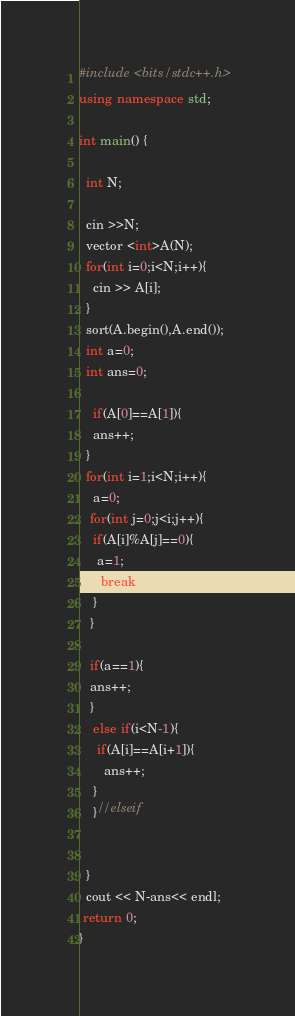<code> <loc_0><loc_0><loc_500><loc_500><_C++_>#include <bits/stdc++.h>
using namespace std;

int main() {

  int N;

  cin >>N;
  vector <int>A(N);
  for(int i=0;i<N;i++){
    cin >> A[i];
  }
  sort(A.begin(),A.end());
  int a=0;
  int ans=0;

    if(A[0]==A[1]){
    ans++;
  }
  for(int i=1;i<N;i++){
    a=0;
   for(int j=0;j<i;j++){
    if(A[i]%A[j]==0){
     a=1;
      break;
    }      
   }
    
   if(a==1){
   ans++;
   }
    else if(i<N-1){
     if(A[i]==A[i+1]){
       ans++;
    }
    }//elseif
      
    
  }
  cout << N-ans<< endl;
 return 0;
}</code> 